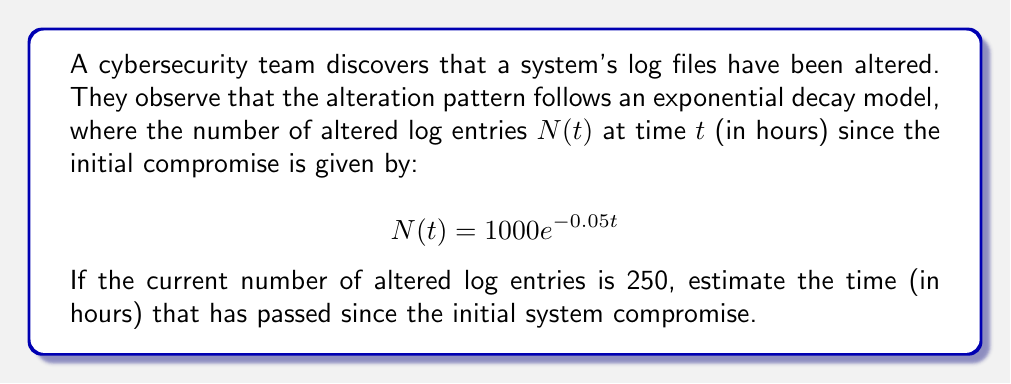Solve this math problem. To solve this inverse problem, we need to determine the time $t$ given the number of altered log entries $N(t)$. Let's approach this step-by-step:

1. We're given the equation: $N(t) = 1000e^{-0.05t}$
2. We know that the current number of altered log entries, $N(t)$, is 250.
3. Let's substitute this into our equation:

   $250 = 1000e^{-0.05t}$

4. Divide both sides by 1000:

   $\frac{250}{1000} = e^{-0.05t}$
   $0.25 = e^{-0.05t}$

5. Take the natural logarithm of both sides:

   $\ln(0.25) = \ln(e^{-0.05t})$
   $\ln(0.25) = -0.05t$

6. Solve for $t$:

   $t = -\frac{\ln(0.25)}{0.05}$

7. Calculate the result:
   $t \approx 27.73$ hours

Therefore, approximately 27.73 hours have passed since the initial system compromise.
Answer: 27.73 hours 